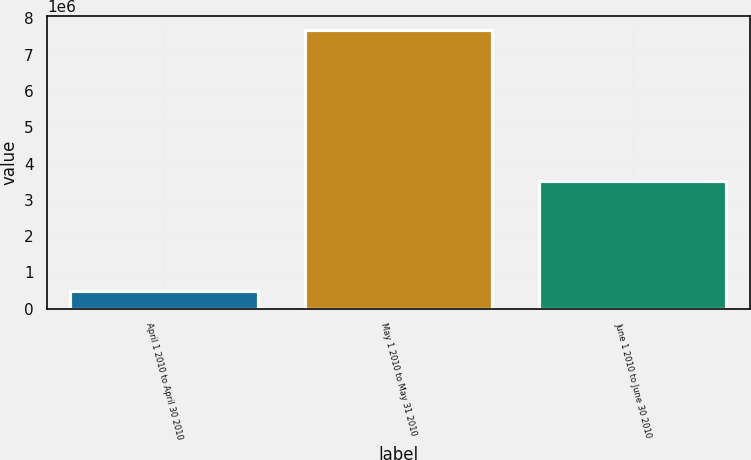Convert chart. <chart><loc_0><loc_0><loc_500><loc_500><bar_chart><fcel>April 1 2010 to April 30 2010<fcel>May 1 2010 to May 31 2010<fcel>June 1 2010 to June 30 2010<nl><fcel>500190<fcel>7.68134e+06<fcel>3.51636e+06<nl></chart> 